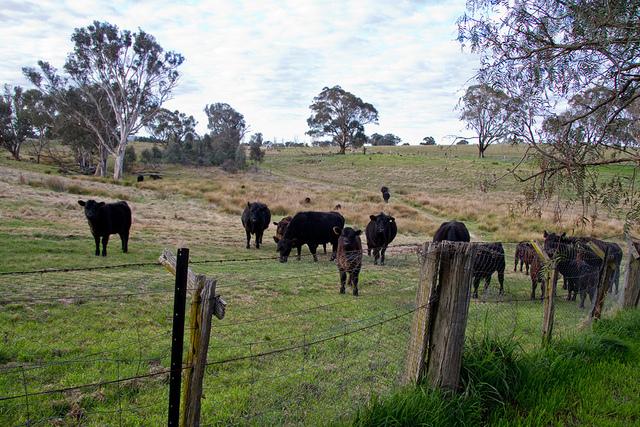Why are the animals fenced in?
Concise answer only. So they don't wander off. How many goats are in the photo?
Answer briefly. 0. Are there sheep in this picture?
Answer briefly. No. 